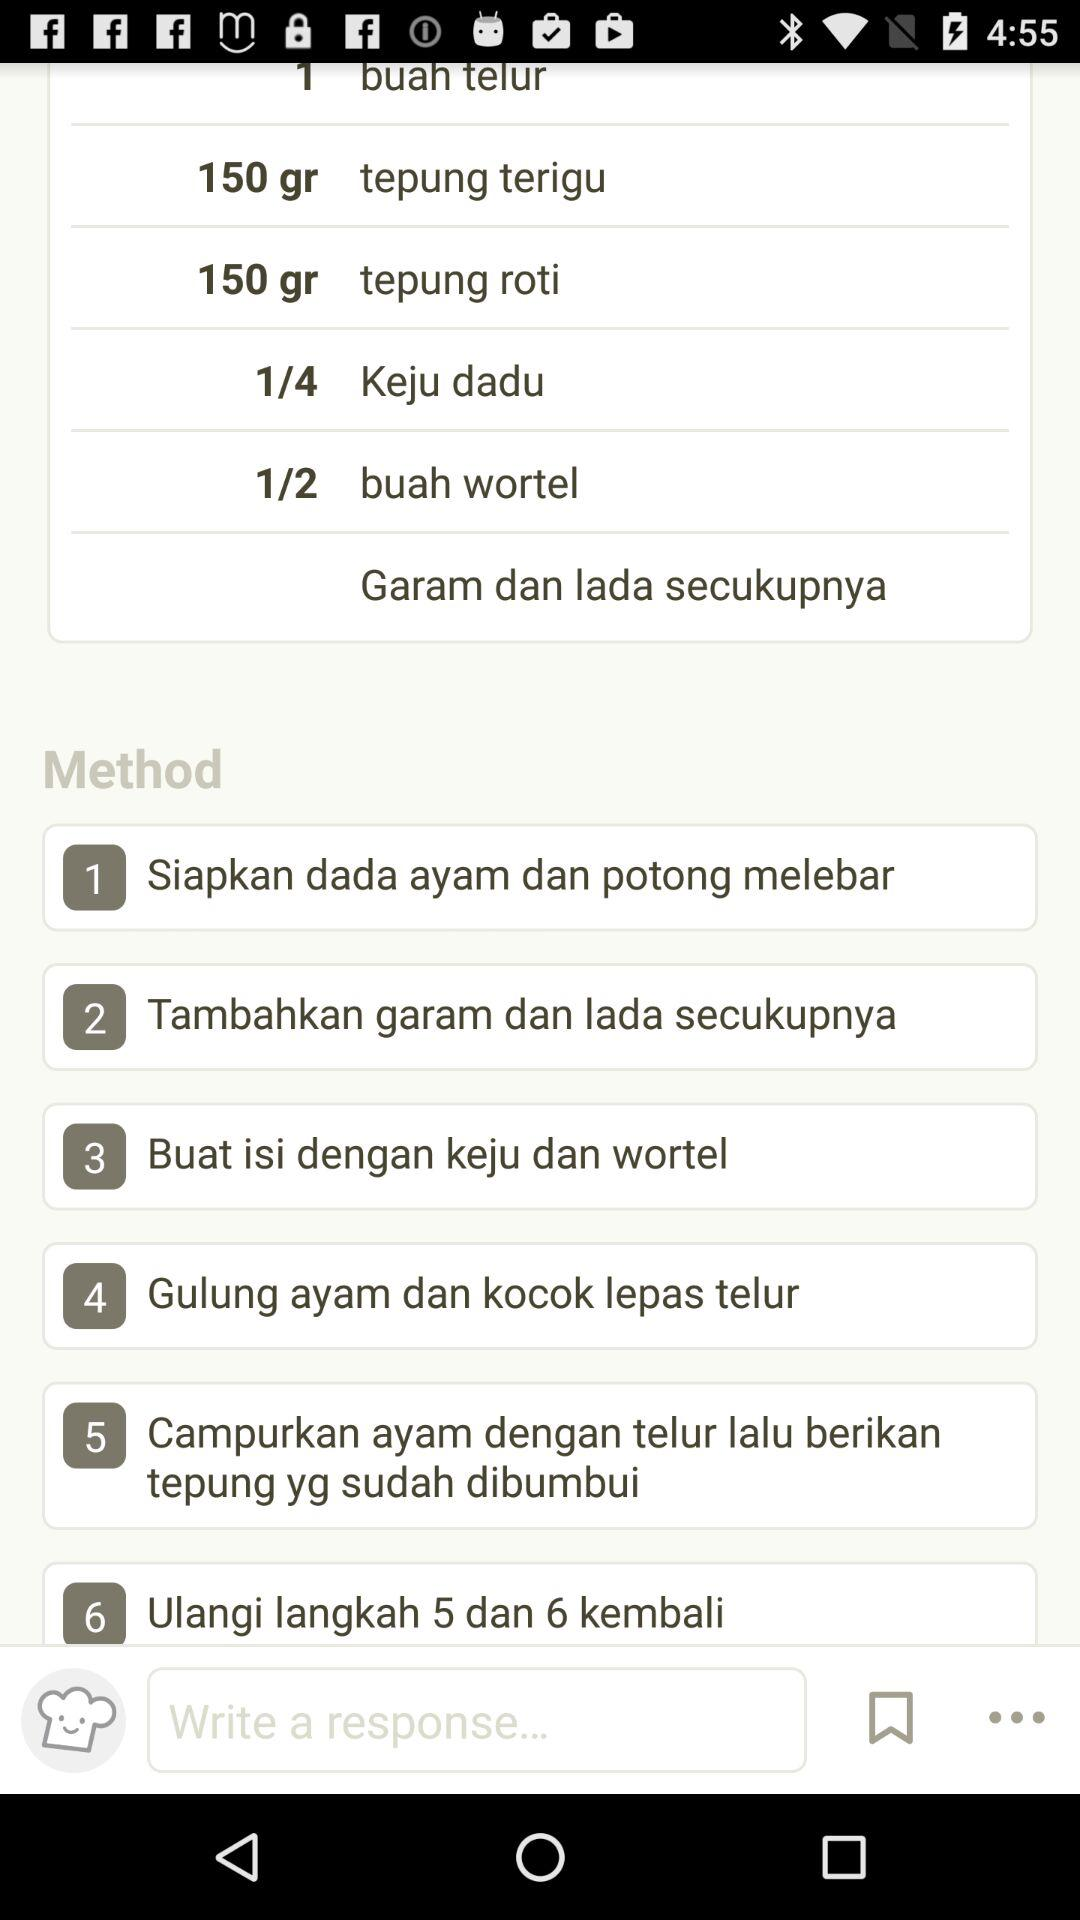How many steps are there in the recipe?
Answer the question using a single word or phrase. 6 